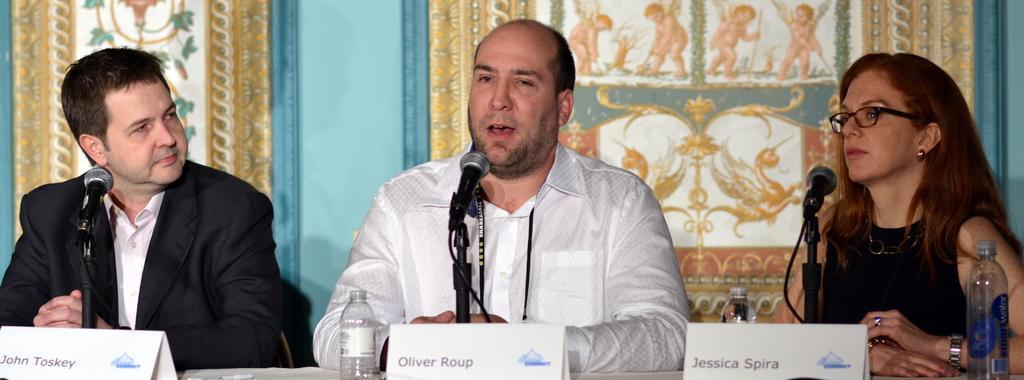Could you give a brief overview of what you see in this image? There are three persons sitting and we can see name boards,bottles,microphones and objects on table. On the background we can see wall. 